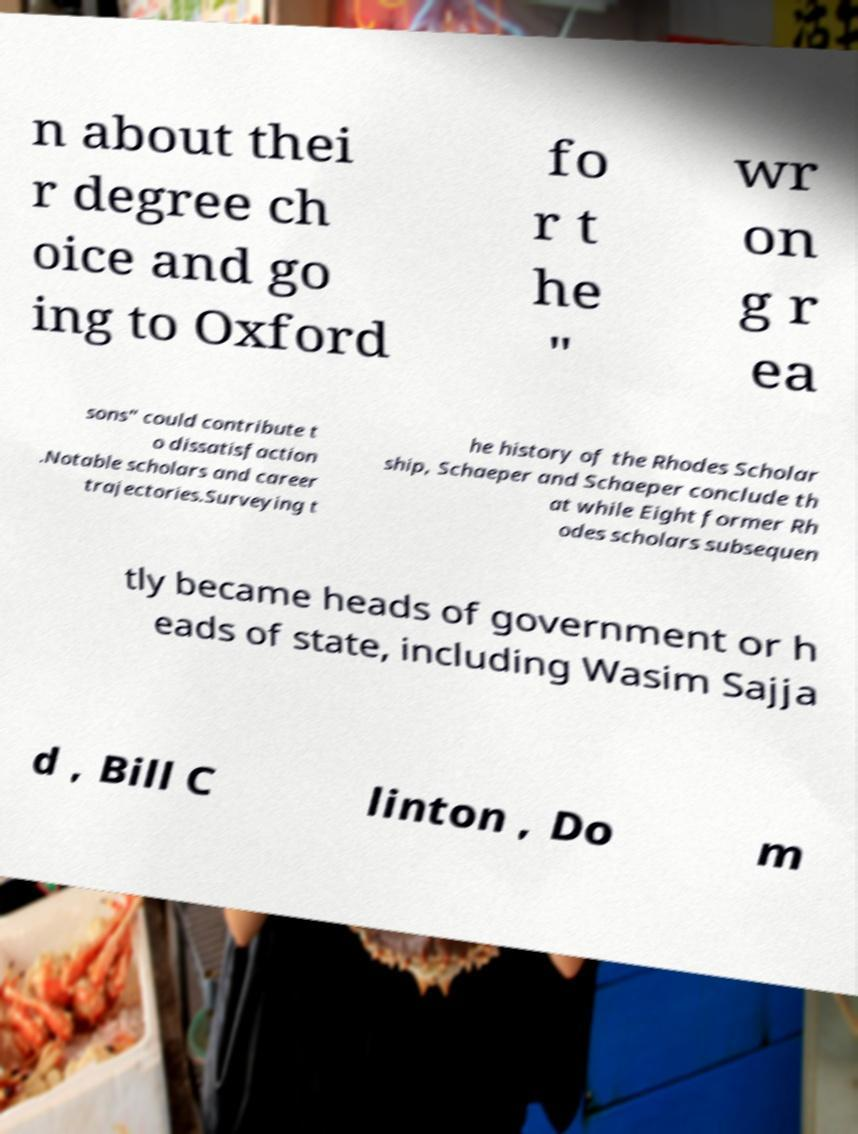I need the written content from this picture converted into text. Can you do that? n about thei r degree ch oice and go ing to Oxford fo r t he " wr on g r ea sons" could contribute t o dissatisfaction .Notable scholars and career trajectories.Surveying t he history of the Rhodes Scholar ship, Schaeper and Schaeper conclude th at while Eight former Rh odes scholars subsequen tly became heads of government or h eads of state, including Wasim Sajja d , Bill C linton , Do m 